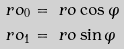Convert formula to latex. <formula><loc_0><loc_0><loc_500><loc_500>\ r o _ { 0 } & = \ r o \cos \varphi \\ \ r o _ { 1 } & = \ r o \sin \varphi</formula> 